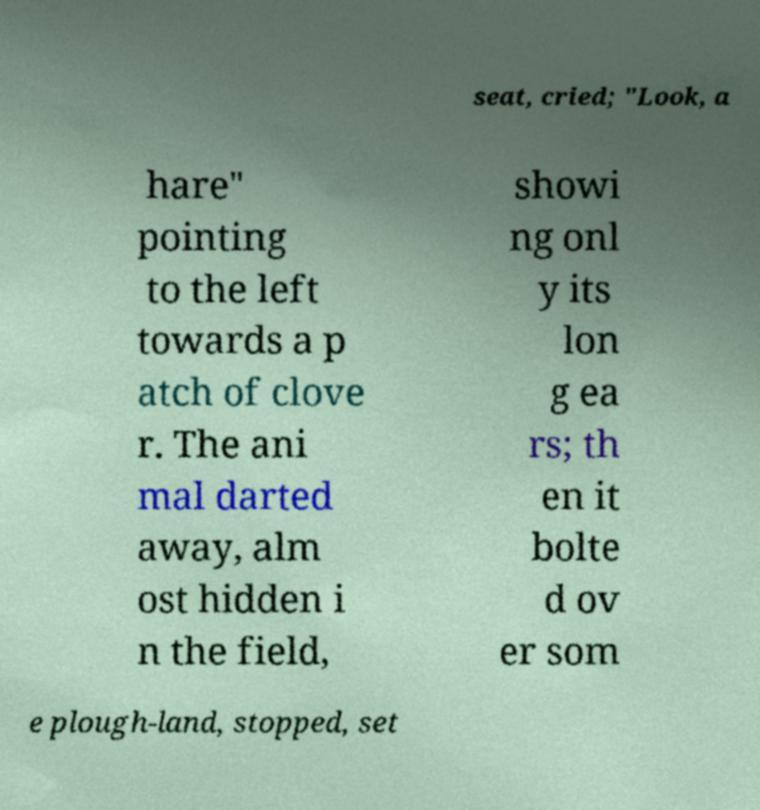Please identify and transcribe the text found in this image. seat, cried; "Look, a hare" pointing to the left towards a p atch of clove r. The ani mal darted away, alm ost hidden i n the field, showi ng onl y its lon g ea rs; th en it bolte d ov er som e plough-land, stopped, set 